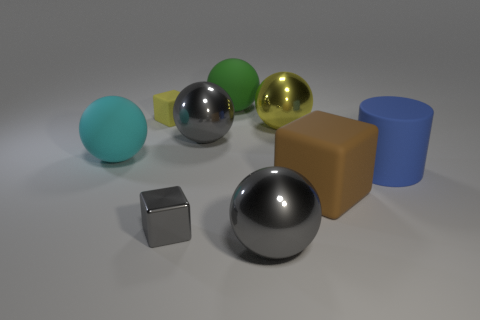What number of other objects are the same color as the big matte block?
Give a very brief answer. 0. There is a sphere to the left of the yellow rubber object; does it have the same size as the yellow matte block?
Keep it short and to the point. No. Is the big gray object behind the gray block made of the same material as the yellow thing that is in front of the tiny yellow rubber object?
Keep it short and to the point. Yes. Are there any other green cylinders that have the same size as the matte cylinder?
Offer a terse response. No. There is a gray object behind the large cylinder that is behind the cube that is right of the small metal object; what shape is it?
Your answer should be compact. Sphere. Is the number of tiny cubes that are on the left side of the tiny gray metal thing greater than the number of red objects?
Offer a very short reply. Yes. Are there any large yellow metal objects that have the same shape as the cyan object?
Your answer should be compact. Yes. Are the yellow ball and the small object on the right side of the small rubber block made of the same material?
Provide a short and direct response. Yes. The cylinder is what color?
Make the answer very short. Blue. There is a cube on the right side of the object in front of the tiny metal block; how many small things are in front of it?
Give a very brief answer. 1. 